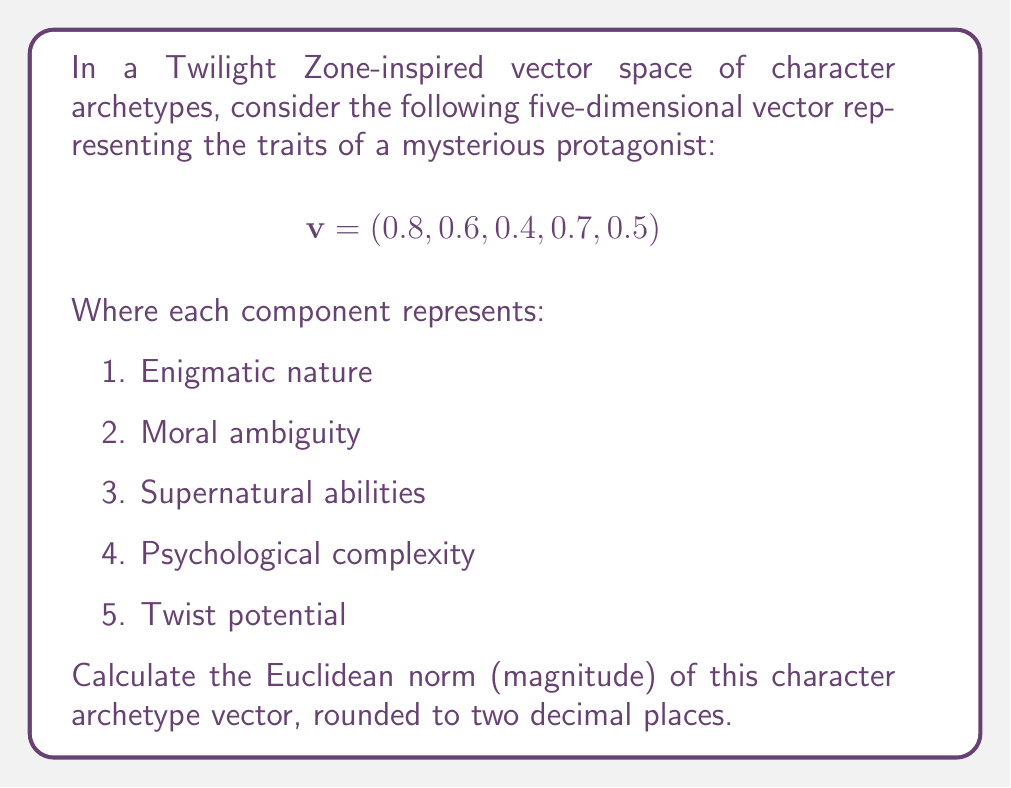Give your solution to this math problem. To calculate the Euclidean norm of the vector, we follow these steps:

1) The Euclidean norm (also known as L2 norm) of a vector $v = (v_1, v_2, ..., v_n)$ is defined as:

   $$\|v\| = \sqrt{\sum_{i=1}^n v_i^2}$$

2) For our vector $v = (0.8, 0.6, 0.4, 0.7, 0.5)$, we need to square each component:

   $0.8^2 = 0.64$
   $0.6^2 = 0.36$
   $0.4^2 = 0.16$
   $0.7^2 = 0.49$
   $0.5^2 = 0.25$

3) Sum these squared values:

   $0.64 + 0.36 + 0.16 + 0.49 + 0.25 = 1.90$

4) Take the square root of the sum:

   $\sqrt{1.90} \approx 1.3784$

5) Rounding to two decimal places:

   $1.38$

Therefore, the Euclidean norm of the character archetype vector is approximately 1.38.
Answer: $1.38$ 